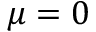Convert formula to latex. <formula><loc_0><loc_0><loc_500><loc_500>\mu = 0</formula> 